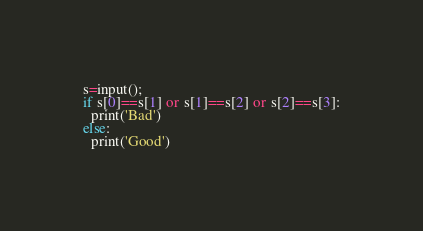<code> <loc_0><loc_0><loc_500><loc_500><_Python_>s=input();
if s[0]==s[1] or s[1]==s[2] or s[2]==s[3]:
  print('Bad')
else:
  print('Good')</code> 